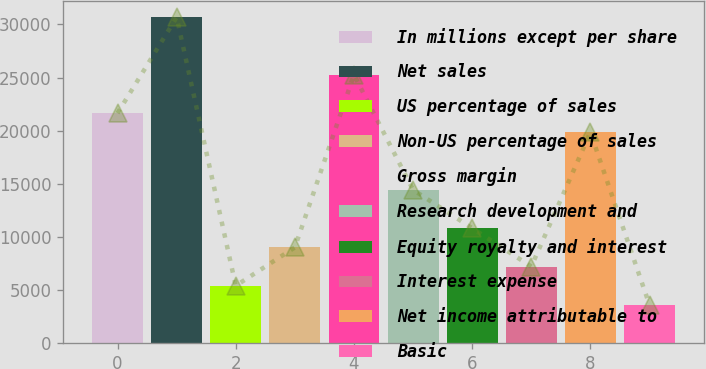Convert chart. <chart><loc_0><loc_0><loc_500><loc_500><bar_chart><fcel>In millions except per share<fcel>Net sales<fcel>US percentage of sales<fcel>Non-US percentage of sales<fcel>Gross margin<fcel>Research development and<fcel>Equity royalty and interest<fcel>Interest expense<fcel>Net income attributable to<fcel>Basic<nl><fcel>21657.4<fcel>30680.7<fcel>5415.33<fcel>9024.67<fcel>25266.7<fcel>14438.7<fcel>10829.3<fcel>7220<fcel>19852.7<fcel>3610.66<nl></chart> 